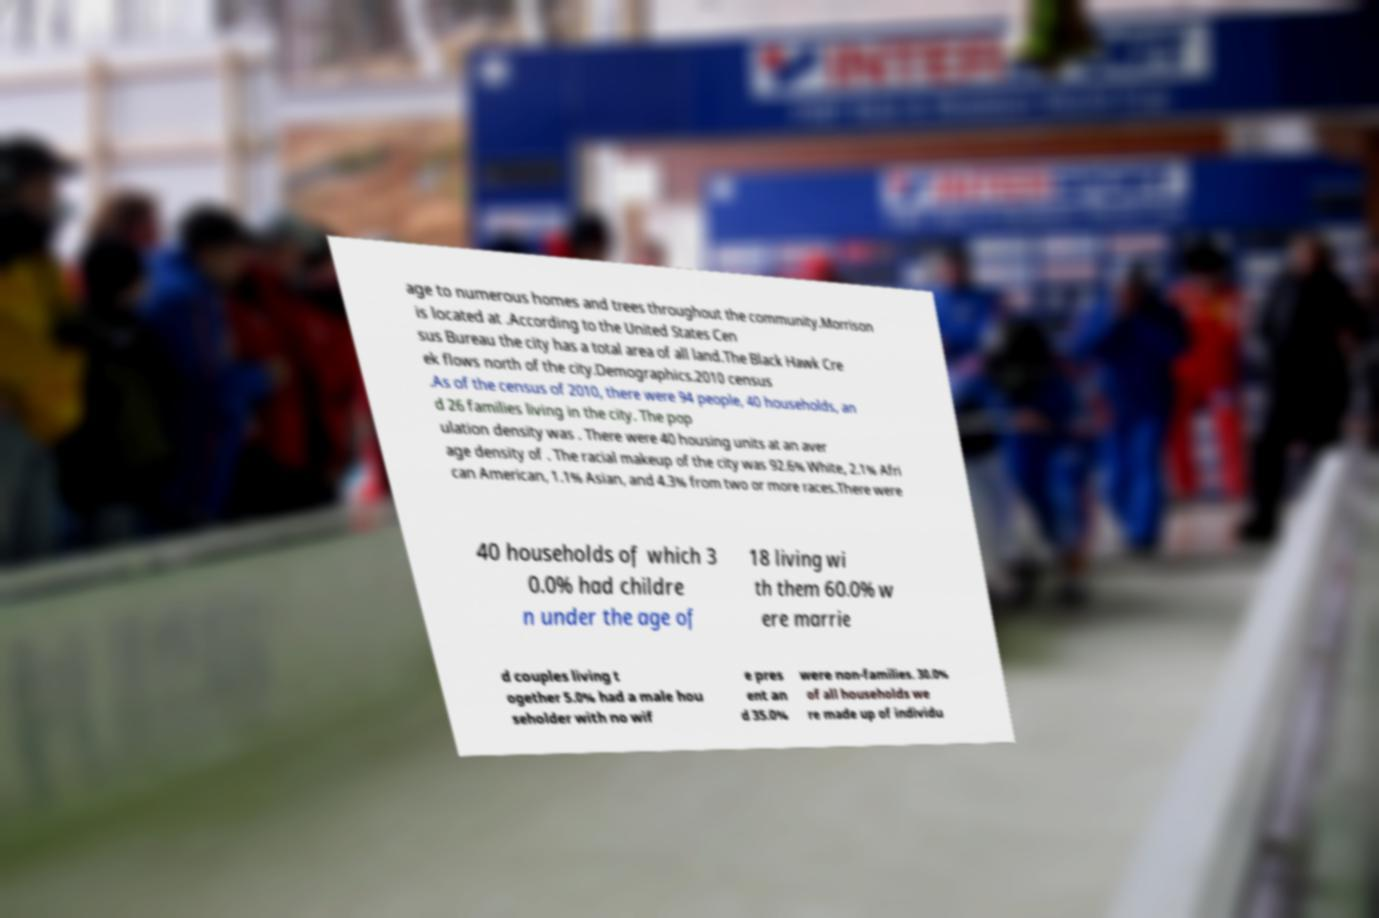I need the written content from this picture converted into text. Can you do that? age to numerous homes and trees throughout the community.Morrison is located at .According to the United States Cen sus Bureau the city has a total area of all land.The Black Hawk Cre ek flows north of the city.Demographics.2010 census .As of the census of 2010, there were 94 people, 40 households, an d 26 families living in the city. The pop ulation density was . There were 40 housing units at an aver age density of . The racial makeup of the city was 92.6% White, 2.1% Afri can American, 1.1% Asian, and 4.3% from two or more races.There were 40 households of which 3 0.0% had childre n under the age of 18 living wi th them 60.0% w ere marrie d couples living t ogether 5.0% had a male hou seholder with no wif e pres ent an d 35.0% were non-families. 30.0% of all households we re made up of individu 